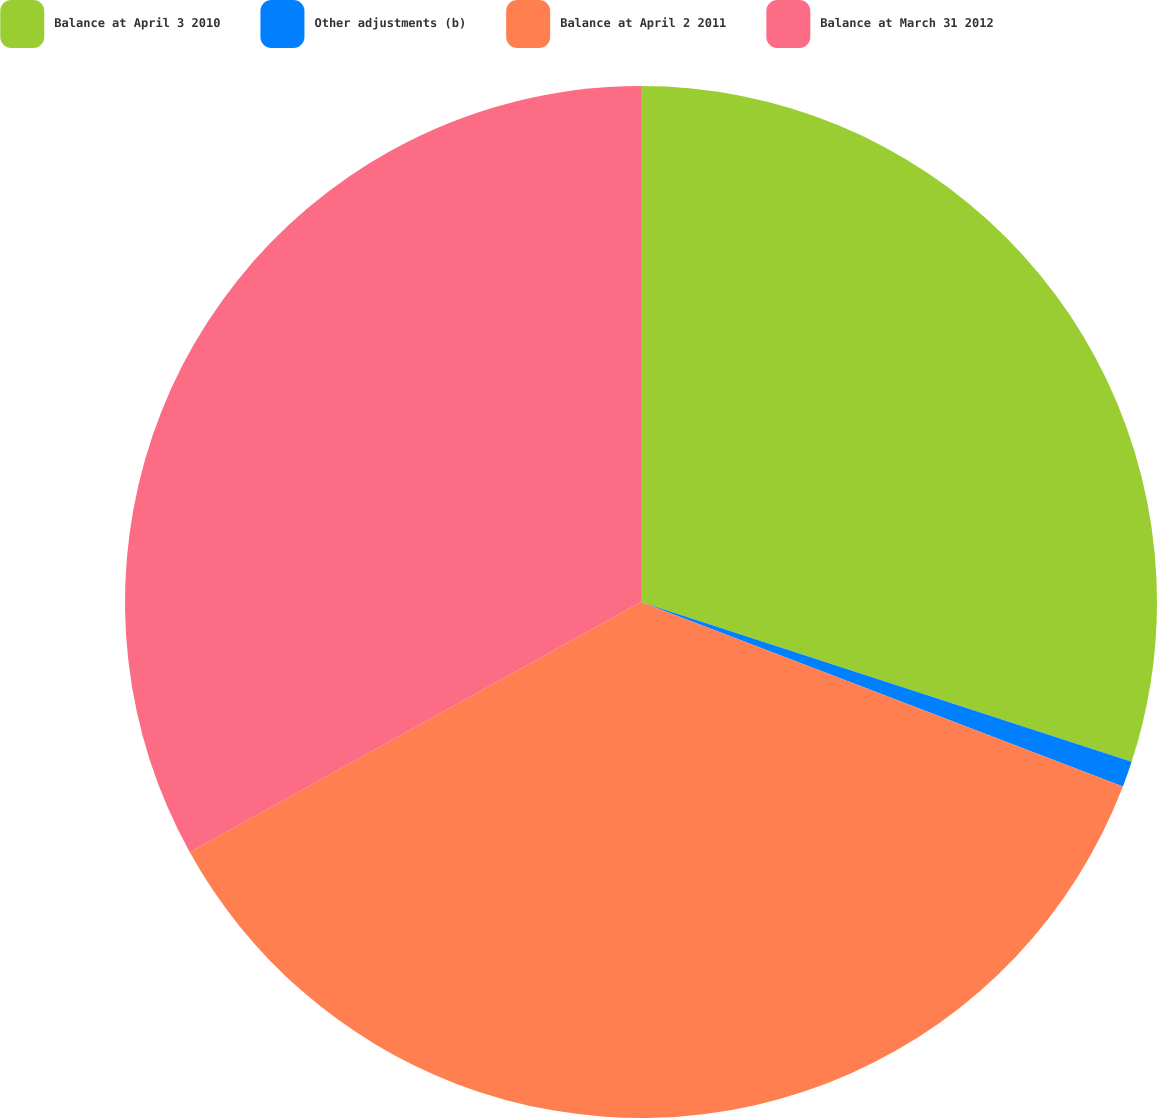<chart> <loc_0><loc_0><loc_500><loc_500><pie_chart><fcel>Balance at April 3 2010<fcel>Other adjustments (b)<fcel>Balance at April 2 2011<fcel>Balance at March 31 2012<nl><fcel>30.01%<fcel>0.81%<fcel>36.12%<fcel>33.06%<nl></chart> 